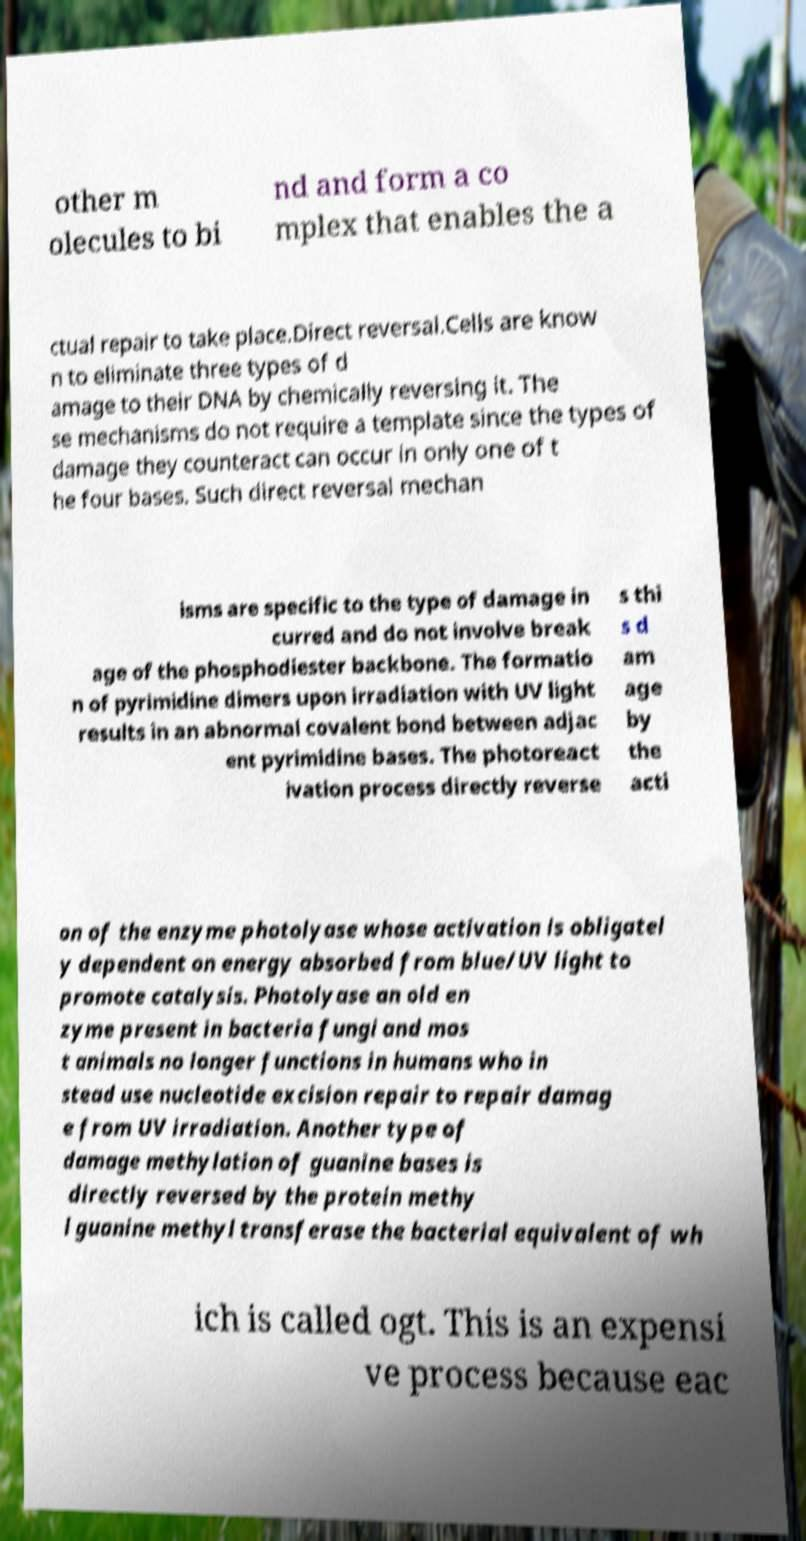Please identify and transcribe the text found in this image. other m olecules to bi nd and form a co mplex that enables the a ctual repair to take place.Direct reversal.Cells are know n to eliminate three types of d amage to their DNA by chemically reversing it. The se mechanisms do not require a template since the types of damage they counteract can occur in only one of t he four bases. Such direct reversal mechan isms are specific to the type of damage in curred and do not involve break age of the phosphodiester backbone. The formatio n of pyrimidine dimers upon irradiation with UV light results in an abnormal covalent bond between adjac ent pyrimidine bases. The photoreact ivation process directly reverse s thi s d am age by the acti on of the enzyme photolyase whose activation is obligatel y dependent on energy absorbed from blue/UV light to promote catalysis. Photolyase an old en zyme present in bacteria fungi and mos t animals no longer functions in humans who in stead use nucleotide excision repair to repair damag e from UV irradiation. Another type of damage methylation of guanine bases is directly reversed by the protein methy l guanine methyl transferase the bacterial equivalent of wh ich is called ogt. This is an expensi ve process because eac 